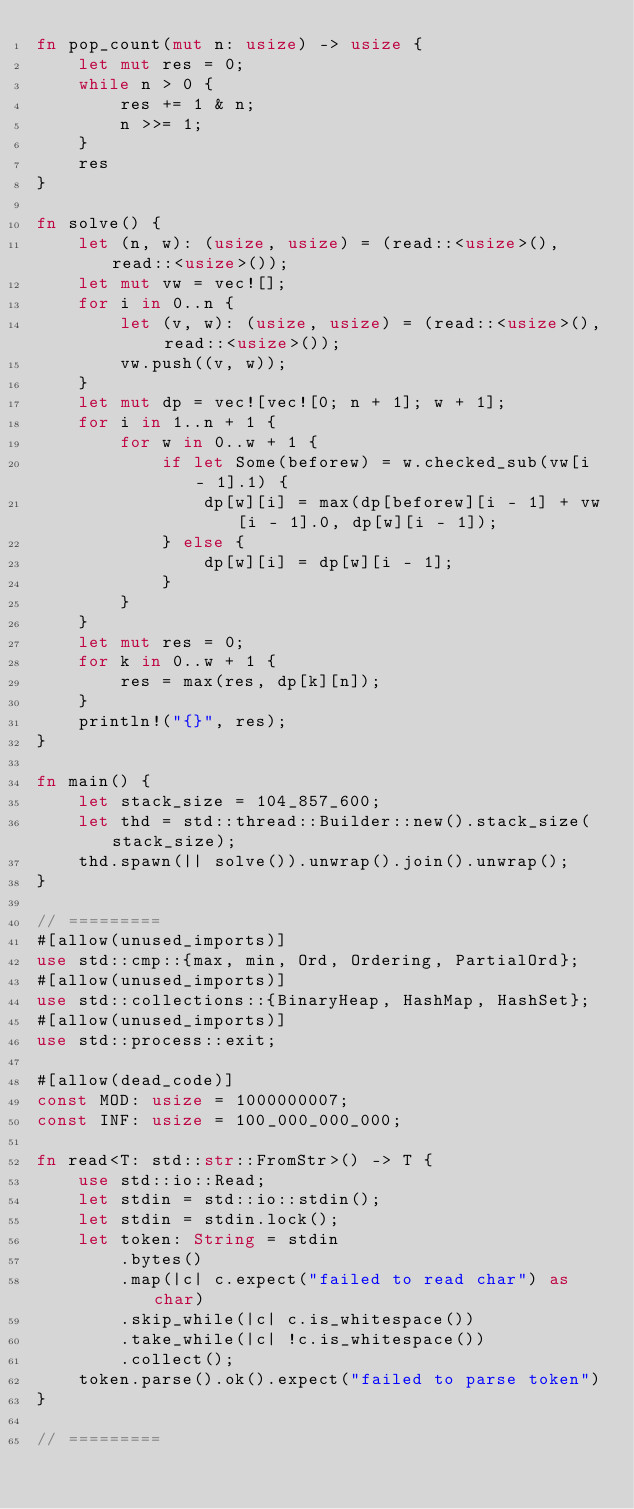<code> <loc_0><loc_0><loc_500><loc_500><_Rust_>fn pop_count(mut n: usize) -> usize {
    let mut res = 0;
    while n > 0 {
        res += 1 & n;
        n >>= 1;
    }
    res
}

fn solve() {
    let (n, w): (usize, usize) = (read::<usize>(), read::<usize>());
    let mut vw = vec![];
    for i in 0..n {
        let (v, w): (usize, usize) = (read::<usize>(), read::<usize>());
        vw.push((v, w));
    }
    let mut dp = vec![vec![0; n + 1]; w + 1];
    for i in 1..n + 1 {
        for w in 0..w + 1 {
            if let Some(beforew) = w.checked_sub(vw[i - 1].1) {
                dp[w][i] = max(dp[beforew][i - 1] + vw[i - 1].0, dp[w][i - 1]);
            } else {
                dp[w][i] = dp[w][i - 1];
            }
        }
    }
    let mut res = 0;
    for k in 0..w + 1 {
        res = max(res, dp[k][n]);
    }
    println!("{}", res);
}

fn main() {
    let stack_size = 104_857_600;
    let thd = std::thread::Builder::new().stack_size(stack_size);
    thd.spawn(|| solve()).unwrap().join().unwrap();
}

// =========
#[allow(unused_imports)]
use std::cmp::{max, min, Ord, Ordering, PartialOrd};
#[allow(unused_imports)]
use std::collections::{BinaryHeap, HashMap, HashSet};
#[allow(unused_imports)]
use std::process::exit;

#[allow(dead_code)]
const MOD: usize = 1000000007;
const INF: usize = 100_000_000_000;

fn read<T: std::str::FromStr>() -> T {
    use std::io::Read;
    let stdin = std::io::stdin();
    let stdin = stdin.lock();
    let token: String = stdin
        .bytes()
        .map(|c| c.expect("failed to read char") as char)
        .skip_while(|c| c.is_whitespace())
        .take_while(|c| !c.is_whitespace())
        .collect();
    token.parse().ok().expect("failed to parse token")
}

// =========

</code> 